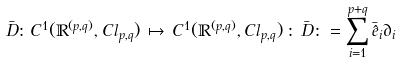<formula> <loc_0><loc_0><loc_500><loc_500>\bar { D } \colon C ^ { 1 } ( { \mathbb { R } } ^ { ( p , q ) } , C l _ { p , q } ) \, \mapsto \, C ^ { 1 } ( { \mathbb { R } } ^ { ( p , q ) } , C l _ { p , q } ) \, \colon \, \bar { D } \colon = \sum _ { i = 1 } ^ { p + q } \bar { \hat { e } } _ { i } \partial _ { i }</formula> 